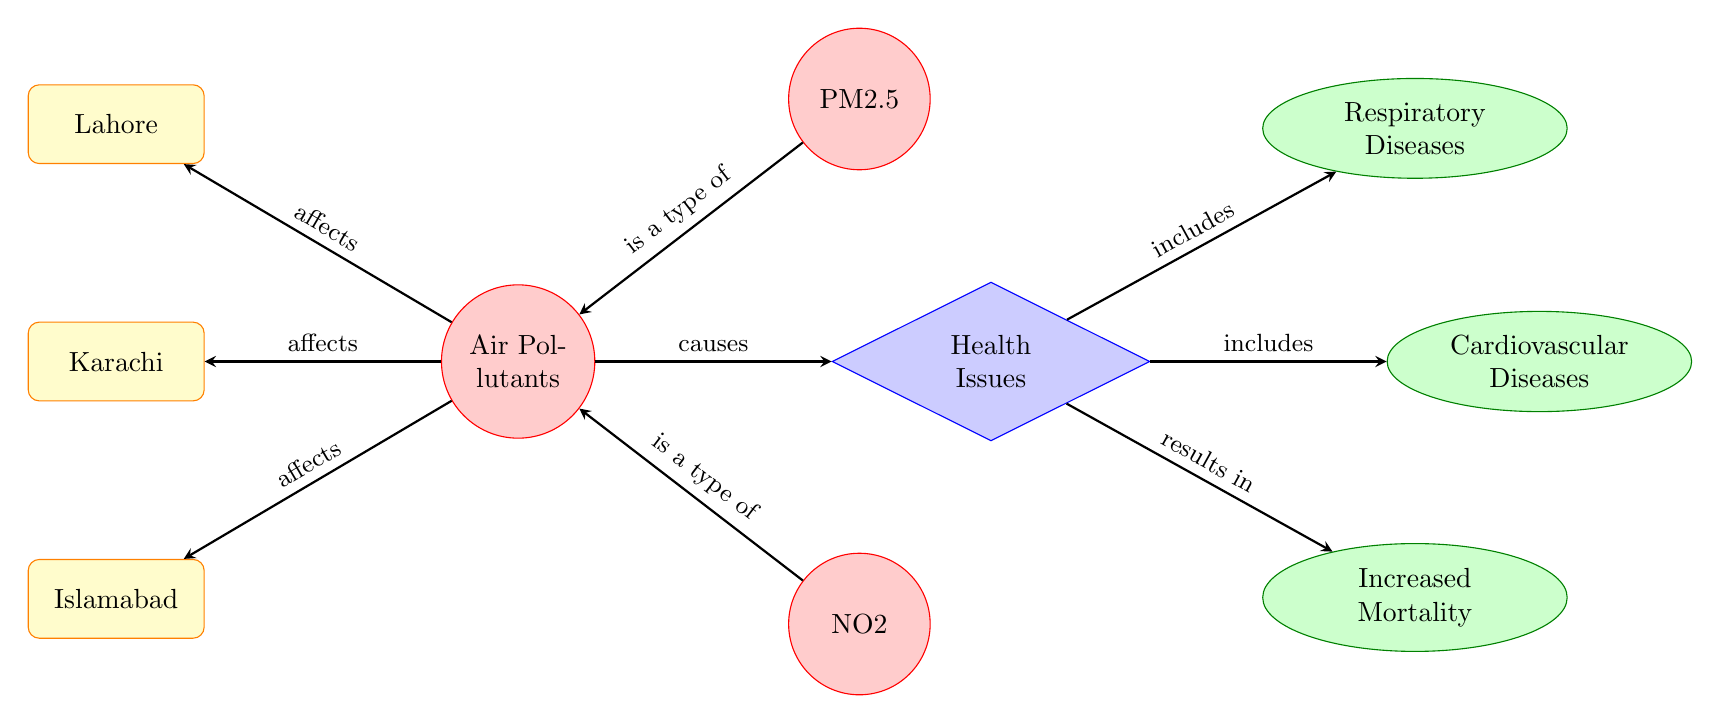What cities are affected by air pollutants? The diagram identifies three major cities impacted by air pollutants: Lahore, Karachi, and Islamabad. Each of these cities is connected with an arrow to the node representing air pollutants, labeled "affects."
Answer: Lahore, Karachi, Islamabad What types of air pollutants are specified in the diagram? The diagram lists PM2.5 and NO2 as the air pollutants. Each pollutant is represented by a circle node connected to the "Air Pollutants" node with arrows indicating their relationship.
Answer: PM2.5, NO2 What health issues are caused by air pollutants? The diagram indicates that air pollutants cause health issues, which is represented by a diamond-shaped node connected to the "Air Pollutants" node. The health issues directly related to air pollutants include Respiratory Diseases, Cardiovascular Diseases, and Increased Mortality.
Answer: Health Issues How many types of health issues are mentioned in the diagram? The diagram shows that there are three types of health issues connected to the "Health Issues" node through arrows indicating inclusion. This encompasses Respiratory Diseases, Cardiovascular Diseases, and Increased Mortality.
Answer: Three What is the relationship between PM2.5 and Air Pollutants? The diagram shows a direct connection between PM2.5 and the "Air Pollutants" node, labeled "is a type of," indicating that PM2.5 is categorized as a type of air pollutant.
Answer: Is a type of Which health issue is the consequence of air pollution according to the diagram? According to the diagram, Increased Mortality is highlighted as a result of health issues caused by air pollutants. The arrow labeled "results in" from the "Health Issues" node leads to the "Increased Mortality" node, illustrating this causal relationship.
Answer: Increased Mortality What color represents health issues in the diagram? The health issues node is represented with a blue fill color, while its shape is a diamond, distinctly indicating its classification in relation to air pollutants.
Answer: Blue Which pollutant is above the other in the diagram? The arrangement shows PM2.5 positioned above NO2 in relation to the "Air Pollutants" node, illustrating their respective places in context within the diagram.
Answer: PM2.5 above NO2 